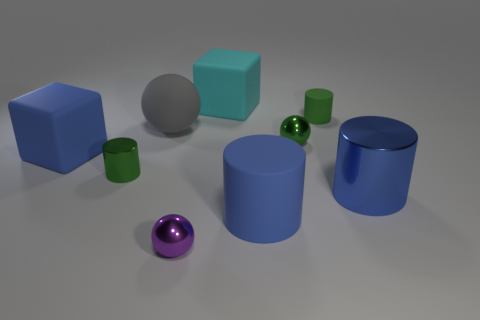Subtract all large blue matte cylinders. How many cylinders are left? 3 Subtract all blocks. How many objects are left? 7 Subtract all blue blocks. How many blue cylinders are left? 2 Subtract all blue cylinders. How many cylinders are left? 2 Subtract 3 balls. How many balls are left? 0 Subtract all large blue metal objects. Subtract all large cyan blocks. How many objects are left? 7 Add 9 gray spheres. How many gray spheres are left? 10 Add 6 green metal spheres. How many green metal spheres exist? 7 Subtract 0 brown spheres. How many objects are left? 9 Subtract all cyan cylinders. Subtract all red blocks. How many cylinders are left? 4 